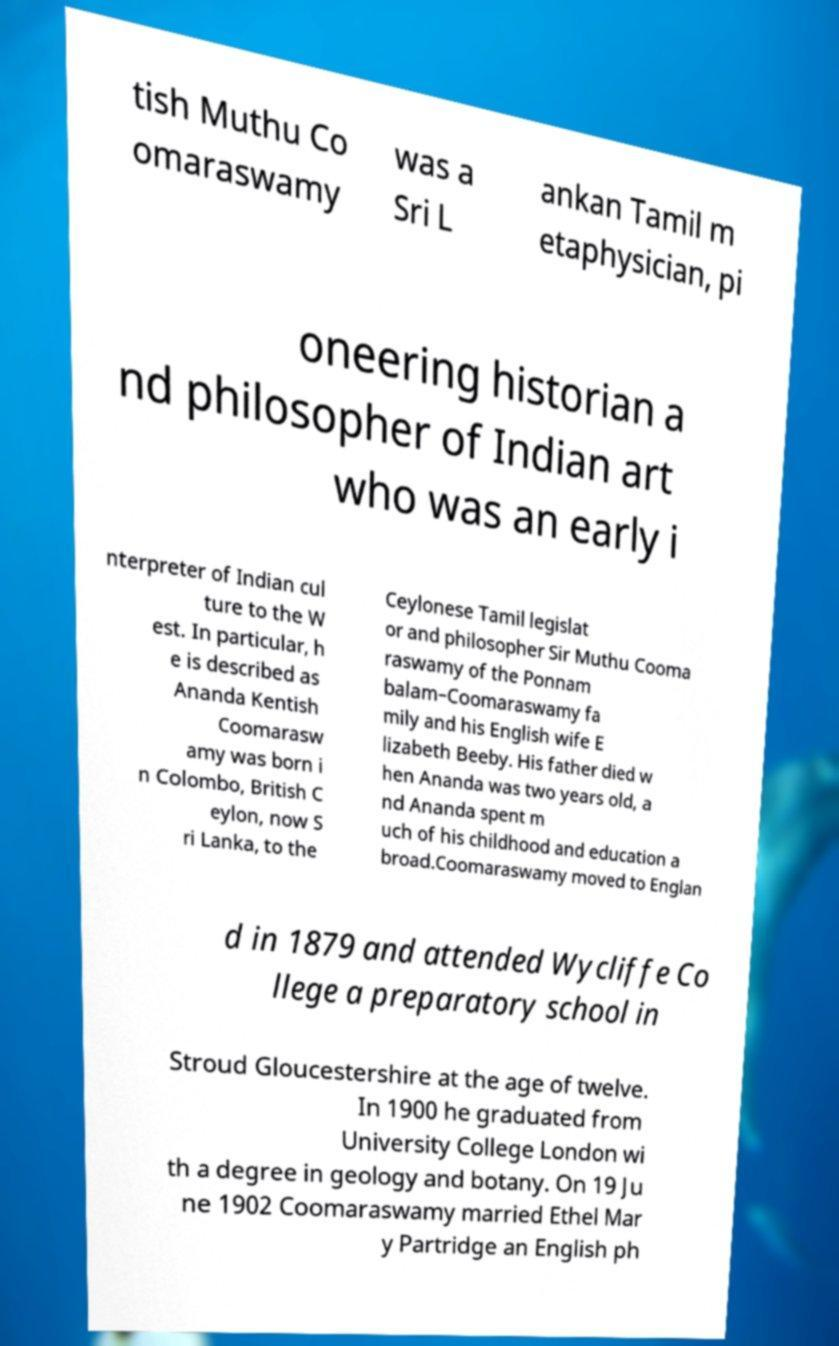Could you extract and type out the text from this image? tish Muthu Co omaraswamy was a Sri L ankan Tamil m etaphysician, pi oneering historian a nd philosopher of Indian art who was an early i nterpreter of Indian cul ture to the W est. In particular, h e is described as Ananda Kentish Coomarasw amy was born i n Colombo, British C eylon, now S ri Lanka, to the Ceylonese Tamil legislat or and philosopher Sir Muthu Cooma raswamy of the Ponnam balam–Coomaraswamy fa mily and his English wife E lizabeth Beeby. His father died w hen Ananda was two years old, a nd Ananda spent m uch of his childhood and education a broad.Coomaraswamy moved to Englan d in 1879 and attended Wycliffe Co llege a preparatory school in Stroud Gloucestershire at the age of twelve. In 1900 he graduated from University College London wi th a degree in geology and botany. On 19 Ju ne 1902 Coomaraswamy married Ethel Mar y Partridge an English ph 